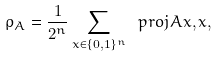<formula> <loc_0><loc_0><loc_500><loc_500>\rho _ { A } = \frac { 1 } { 2 ^ { n } } \sum _ { x \in \{ 0 , 1 \} ^ { n } } \ p r o j { A x , x } ,</formula> 